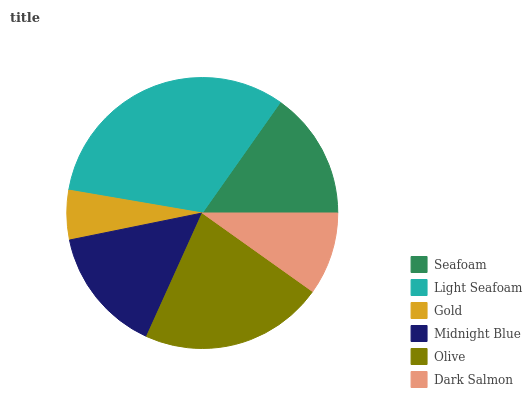Is Gold the minimum?
Answer yes or no. Yes. Is Light Seafoam the maximum?
Answer yes or no. Yes. Is Light Seafoam the minimum?
Answer yes or no. No. Is Gold the maximum?
Answer yes or no. No. Is Light Seafoam greater than Gold?
Answer yes or no. Yes. Is Gold less than Light Seafoam?
Answer yes or no. Yes. Is Gold greater than Light Seafoam?
Answer yes or no. No. Is Light Seafoam less than Gold?
Answer yes or no. No. Is Seafoam the high median?
Answer yes or no. Yes. Is Midnight Blue the low median?
Answer yes or no. Yes. Is Midnight Blue the high median?
Answer yes or no. No. Is Light Seafoam the low median?
Answer yes or no. No. 